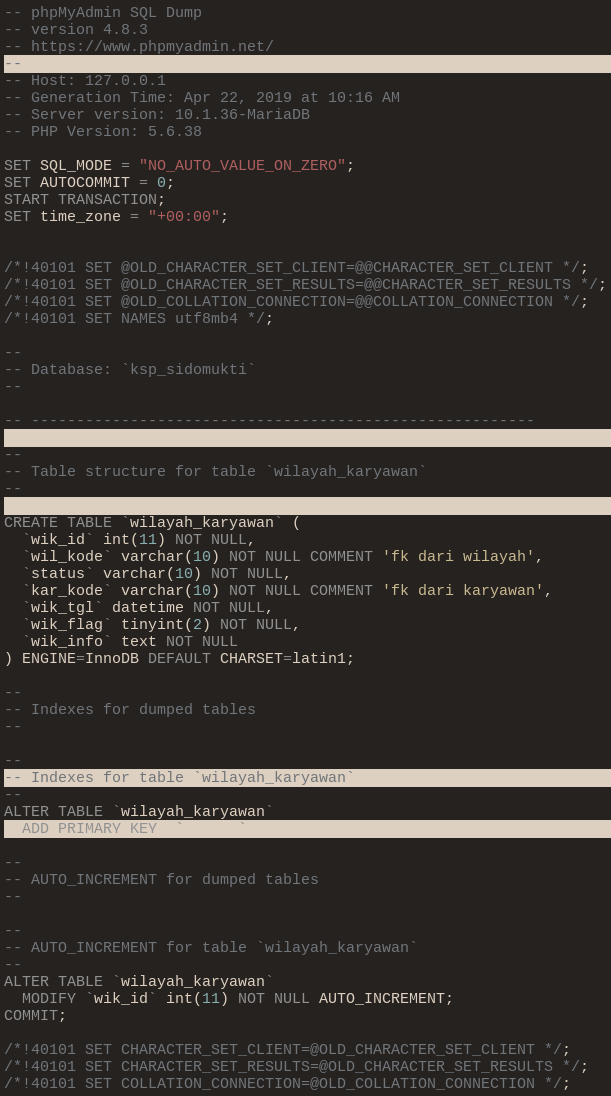<code> <loc_0><loc_0><loc_500><loc_500><_SQL_>-- phpMyAdmin SQL Dump
-- version 4.8.3
-- https://www.phpmyadmin.net/
--
-- Host: 127.0.0.1
-- Generation Time: Apr 22, 2019 at 10:16 AM
-- Server version: 10.1.36-MariaDB
-- PHP Version: 5.6.38

SET SQL_MODE = "NO_AUTO_VALUE_ON_ZERO";
SET AUTOCOMMIT = 0;
START TRANSACTION;
SET time_zone = "+00:00";


/*!40101 SET @OLD_CHARACTER_SET_CLIENT=@@CHARACTER_SET_CLIENT */;
/*!40101 SET @OLD_CHARACTER_SET_RESULTS=@@CHARACTER_SET_RESULTS */;
/*!40101 SET @OLD_COLLATION_CONNECTION=@@COLLATION_CONNECTION */;
/*!40101 SET NAMES utf8mb4 */;

--
-- Database: `ksp_sidomukti`
--

-- --------------------------------------------------------

--
-- Table structure for table `wilayah_karyawan`
--

CREATE TABLE `wilayah_karyawan` (
  `wik_id` int(11) NOT NULL,
  `wil_kode` varchar(10) NOT NULL COMMENT 'fk dari wilayah',
  `status` varchar(10) NOT NULL,
  `kar_kode` varchar(10) NOT NULL COMMENT 'fk dari karyawan',
  `wik_tgl` datetime NOT NULL,
  `wik_flag` tinyint(2) NOT NULL,
  `wik_info` text NOT NULL
) ENGINE=InnoDB DEFAULT CHARSET=latin1;

--
-- Indexes for dumped tables
--

--
-- Indexes for table `wilayah_karyawan`
--
ALTER TABLE `wilayah_karyawan`
  ADD PRIMARY KEY (`wik_id`);

--
-- AUTO_INCREMENT for dumped tables
--

--
-- AUTO_INCREMENT for table `wilayah_karyawan`
--
ALTER TABLE `wilayah_karyawan`
  MODIFY `wik_id` int(11) NOT NULL AUTO_INCREMENT;
COMMIT;

/*!40101 SET CHARACTER_SET_CLIENT=@OLD_CHARACTER_SET_CLIENT */;
/*!40101 SET CHARACTER_SET_RESULTS=@OLD_CHARACTER_SET_RESULTS */;
/*!40101 SET COLLATION_CONNECTION=@OLD_COLLATION_CONNECTION */;
</code> 